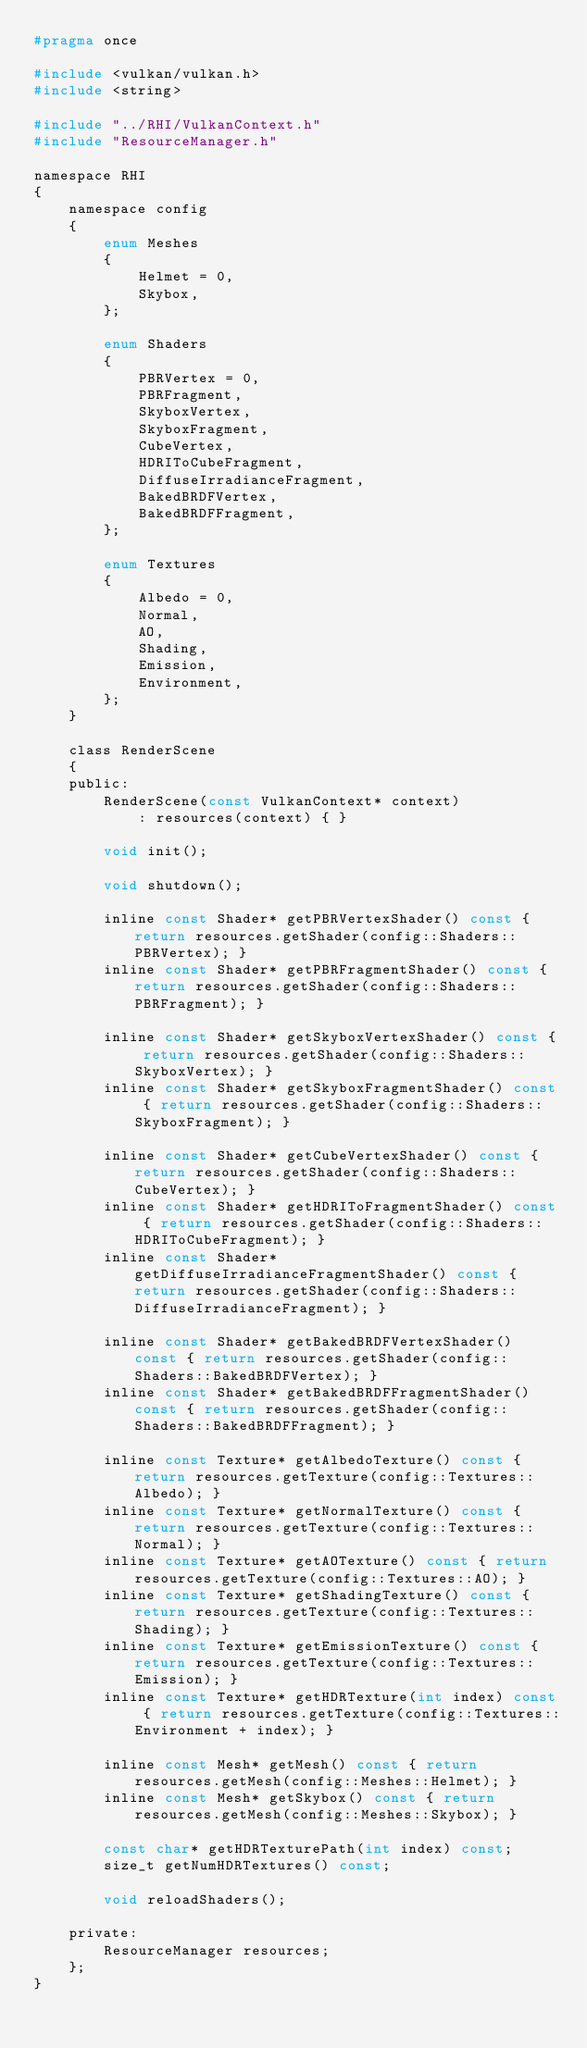<code> <loc_0><loc_0><loc_500><loc_500><_C_>#pragma once

#include <vulkan/vulkan.h>
#include <string>

#include "../RHI/VulkanContext.h"
#include "ResourceManager.h"

namespace RHI
{
	namespace config
	{
		enum Meshes
		{
			Helmet = 0,
			Skybox,
		};

		enum Shaders
		{
			PBRVertex = 0,
			PBRFragment,
			SkyboxVertex,
			SkyboxFragment,
			CubeVertex,
			HDRIToCubeFragment,
			DiffuseIrradianceFragment,
			BakedBRDFVertex,
			BakedBRDFFragment,
		};

		enum Textures
		{
			Albedo = 0,
			Normal,
			AO,
			Shading,
			Emission,
			Environment,
		};
	}

	class RenderScene
	{
	public:
		RenderScene(const VulkanContext* context)
			: resources(context) { }

		void init();

		void shutdown();

		inline const Shader* getPBRVertexShader() const { return resources.getShader(config::Shaders::PBRVertex); }
		inline const Shader* getPBRFragmentShader() const { return resources.getShader(config::Shaders::PBRFragment); }

		inline const Shader* getSkyboxVertexShader() const { return resources.getShader(config::Shaders::SkyboxVertex); }
		inline const Shader* getSkyboxFragmentShader() const { return resources.getShader(config::Shaders::SkyboxFragment); }

		inline const Shader* getCubeVertexShader() const { return resources.getShader(config::Shaders::CubeVertex); }
		inline const Shader* getHDRIToFragmentShader() const { return resources.getShader(config::Shaders::HDRIToCubeFragment); }
		inline const Shader* getDiffuseIrradianceFragmentShader() const { return resources.getShader(config::Shaders::DiffuseIrradianceFragment); }

		inline const Shader* getBakedBRDFVertexShader() const { return resources.getShader(config::Shaders::BakedBRDFVertex); }
		inline const Shader* getBakedBRDFFragmentShader() const { return resources.getShader(config::Shaders::BakedBRDFFragment); }

		inline const Texture* getAlbedoTexture() const { return resources.getTexture(config::Textures::Albedo); }
		inline const Texture* getNormalTexture() const { return resources.getTexture(config::Textures::Normal); }
		inline const Texture* getAOTexture() const { return resources.getTexture(config::Textures::AO); }
		inline const Texture* getShadingTexture() const { return resources.getTexture(config::Textures::Shading); }
		inline const Texture* getEmissionTexture() const { return resources.getTexture(config::Textures::Emission); }
		inline const Texture* getHDRTexture(int index) const { return resources.getTexture(config::Textures::Environment + index); }

		inline const Mesh* getMesh() const { return resources.getMesh(config::Meshes::Helmet); }
		inline const Mesh* getSkybox() const { return resources.getMesh(config::Meshes::Skybox); }

		const char* getHDRTexturePath(int index) const;
		size_t getNumHDRTextures() const;

		void reloadShaders();

	private:
		ResourceManager resources;
	};
}</code> 